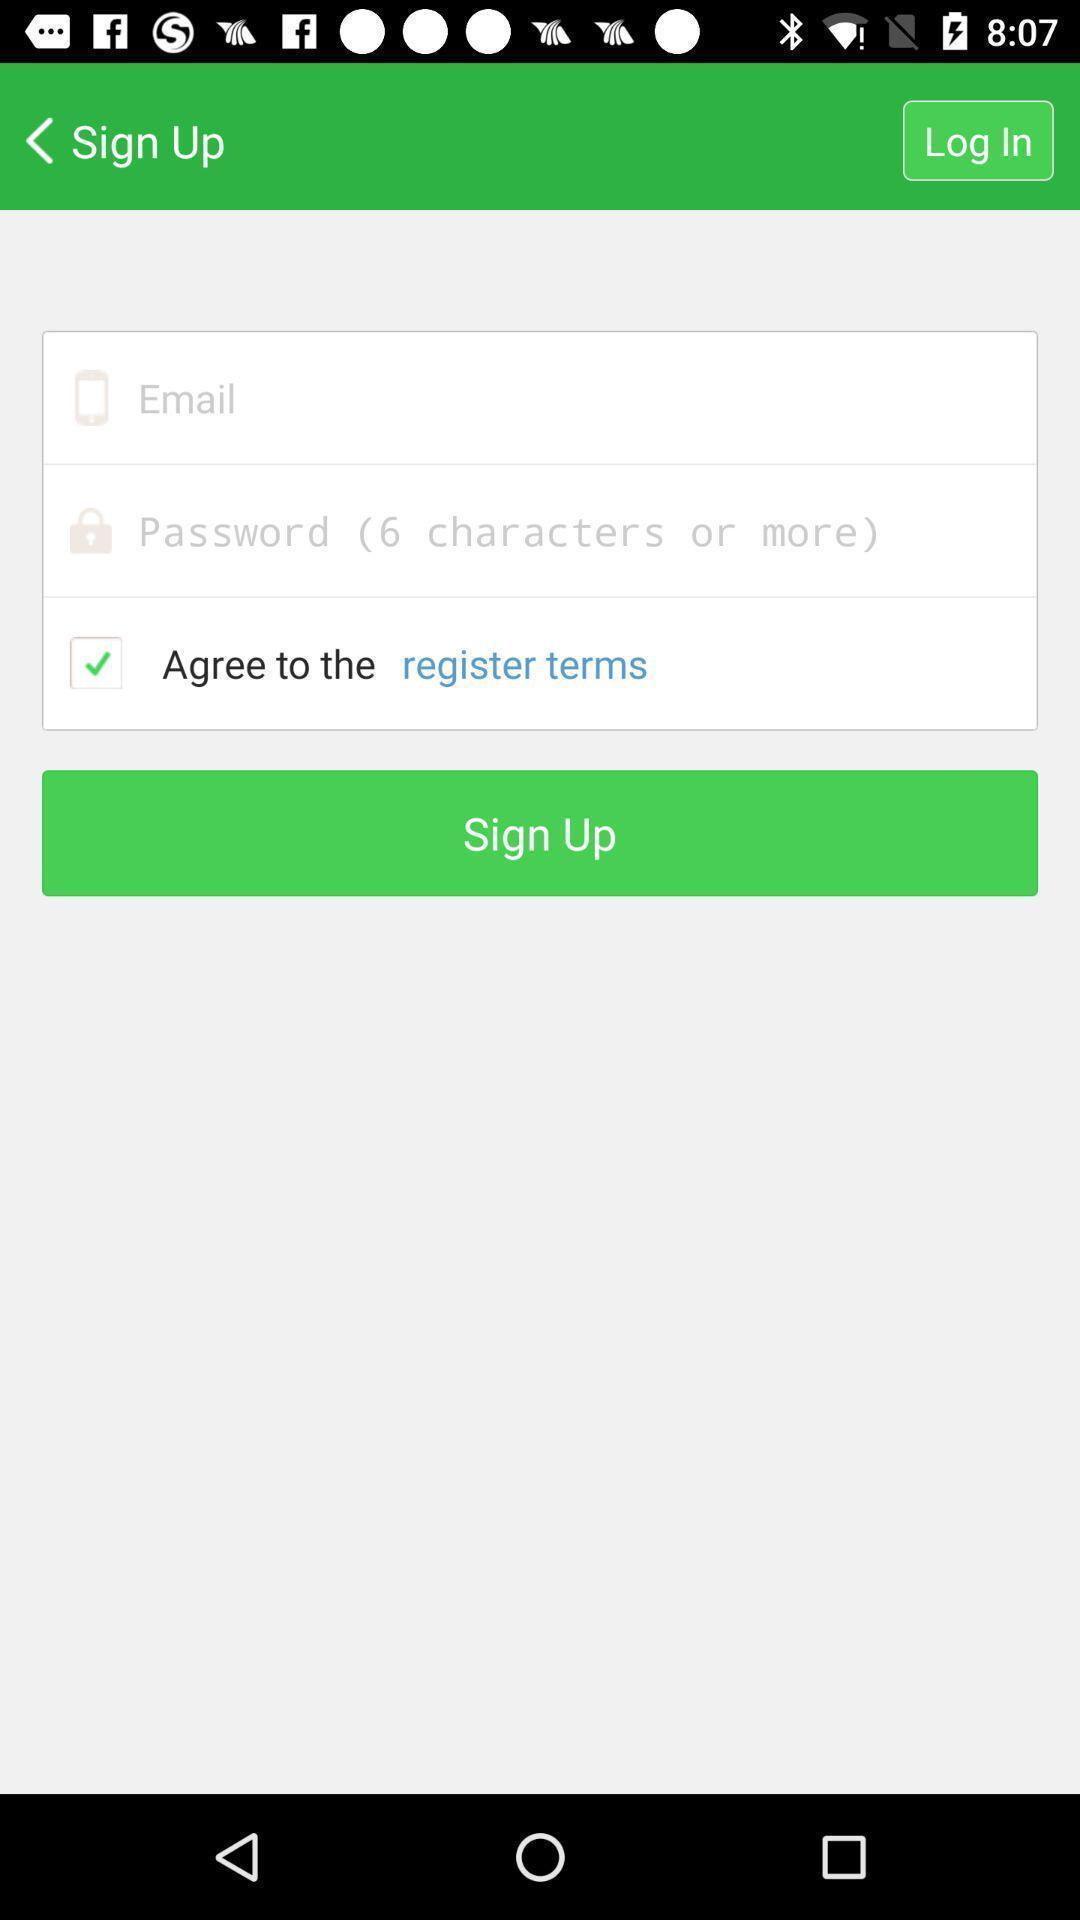What is the overall content of this screenshot? Sign up page. 